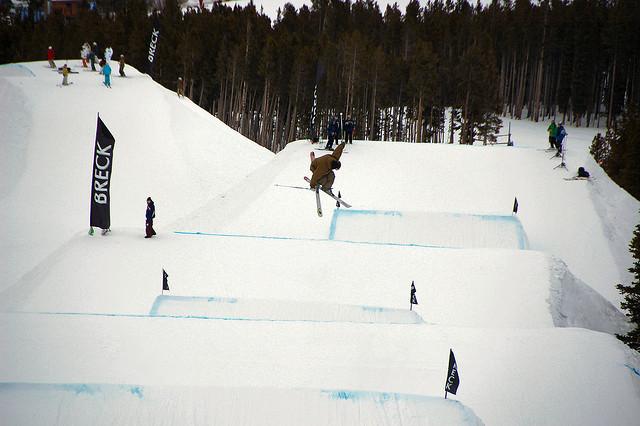Was this photo taken near mountains?
Quick response, please. Yes. Is it cold outside?
Answer briefly. Yes. What does the flag say backwards?
Be succinct. Kcerb. 